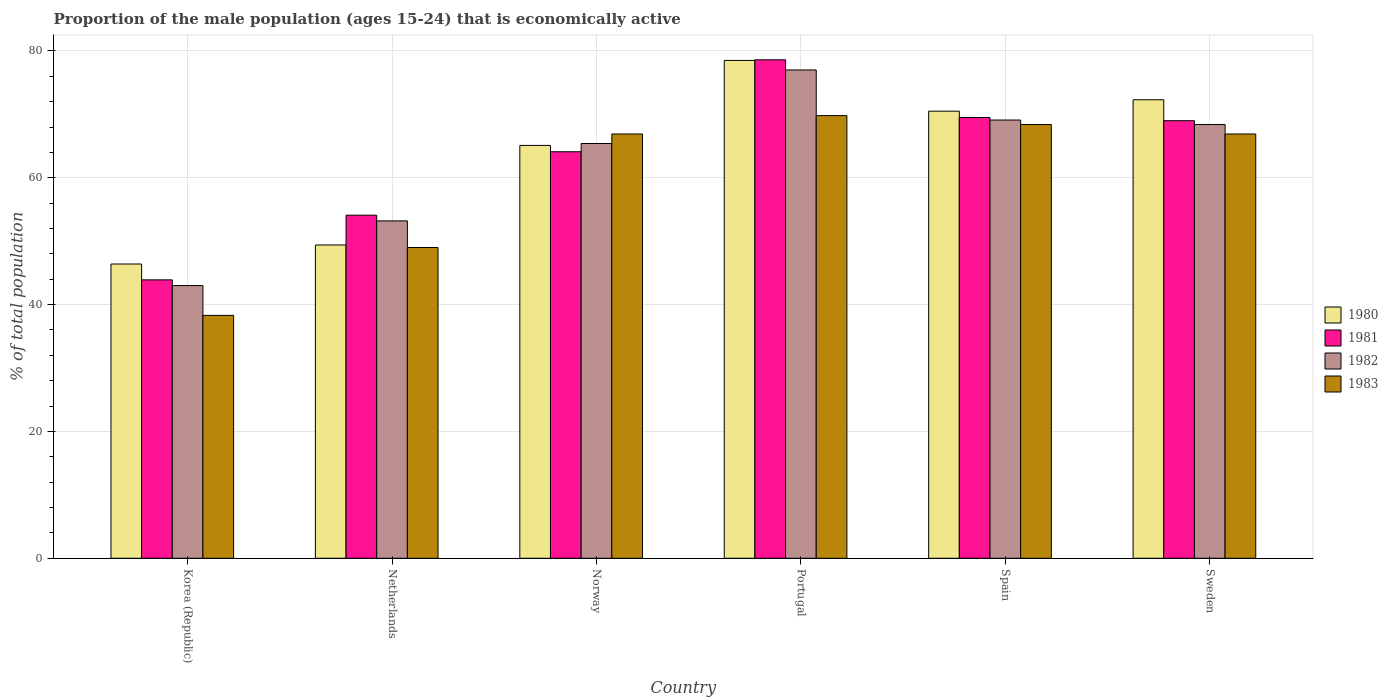Are the number of bars per tick equal to the number of legend labels?
Offer a very short reply. Yes. Are the number of bars on each tick of the X-axis equal?
Provide a succinct answer. Yes. How many bars are there on the 5th tick from the left?
Your answer should be compact. 4. What is the label of the 6th group of bars from the left?
Make the answer very short. Sweden. What is the proportion of the male population that is economically active in 1983 in Sweden?
Offer a very short reply. 66.9. Across all countries, what is the maximum proportion of the male population that is economically active in 1980?
Provide a succinct answer. 78.5. What is the total proportion of the male population that is economically active in 1982 in the graph?
Your answer should be compact. 376.1. What is the difference between the proportion of the male population that is economically active in 1981 in Netherlands and that in Norway?
Keep it short and to the point. -10. What is the difference between the proportion of the male population that is economically active in 1982 in Norway and the proportion of the male population that is economically active in 1983 in Korea (Republic)?
Your answer should be very brief. 27.1. What is the average proportion of the male population that is economically active in 1983 per country?
Make the answer very short. 59.88. What is the difference between the proportion of the male population that is economically active of/in 1981 and proportion of the male population that is economically active of/in 1983 in Korea (Republic)?
Offer a terse response. 5.6. In how many countries, is the proportion of the male population that is economically active in 1983 greater than 48 %?
Your response must be concise. 5. What is the ratio of the proportion of the male population that is economically active in 1981 in Spain to that in Sweden?
Offer a very short reply. 1.01. Is the difference between the proportion of the male population that is economically active in 1981 in Portugal and Spain greater than the difference between the proportion of the male population that is economically active in 1983 in Portugal and Spain?
Your response must be concise. Yes. What is the difference between the highest and the second highest proportion of the male population that is economically active in 1982?
Provide a succinct answer. -7.9. What is the difference between the highest and the lowest proportion of the male population that is economically active in 1981?
Provide a short and direct response. 34.7. Is the sum of the proportion of the male population that is economically active in 1981 in Netherlands and Norway greater than the maximum proportion of the male population that is economically active in 1983 across all countries?
Make the answer very short. Yes. Is it the case that in every country, the sum of the proportion of the male population that is economically active in 1980 and proportion of the male population that is economically active in 1983 is greater than the sum of proportion of the male population that is economically active in 1982 and proportion of the male population that is economically active in 1981?
Make the answer very short. No. How many bars are there?
Give a very brief answer. 24. How many countries are there in the graph?
Keep it short and to the point. 6. How are the legend labels stacked?
Provide a short and direct response. Vertical. What is the title of the graph?
Your answer should be compact. Proportion of the male population (ages 15-24) that is economically active. What is the label or title of the Y-axis?
Your response must be concise. % of total population. What is the % of total population of 1980 in Korea (Republic)?
Your response must be concise. 46.4. What is the % of total population of 1981 in Korea (Republic)?
Offer a terse response. 43.9. What is the % of total population of 1982 in Korea (Republic)?
Give a very brief answer. 43. What is the % of total population of 1983 in Korea (Republic)?
Make the answer very short. 38.3. What is the % of total population of 1980 in Netherlands?
Offer a very short reply. 49.4. What is the % of total population in 1981 in Netherlands?
Provide a succinct answer. 54.1. What is the % of total population in 1982 in Netherlands?
Make the answer very short. 53.2. What is the % of total population of 1980 in Norway?
Provide a short and direct response. 65.1. What is the % of total population of 1981 in Norway?
Your response must be concise. 64.1. What is the % of total population of 1982 in Norway?
Your response must be concise. 65.4. What is the % of total population in 1983 in Norway?
Offer a very short reply. 66.9. What is the % of total population in 1980 in Portugal?
Keep it short and to the point. 78.5. What is the % of total population of 1981 in Portugal?
Ensure brevity in your answer.  78.6. What is the % of total population in 1982 in Portugal?
Your answer should be compact. 77. What is the % of total population in 1983 in Portugal?
Provide a succinct answer. 69.8. What is the % of total population in 1980 in Spain?
Ensure brevity in your answer.  70.5. What is the % of total population in 1981 in Spain?
Keep it short and to the point. 69.5. What is the % of total population in 1982 in Spain?
Offer a terse response. 69.1. What is the % of total population in 1983 in Spain?
Make the answer very short. 68.4. What is the % of total population in 1980 in Sweden?
Give a very brief answer. 72.3. What is the % of total population in 1982 in Sweden?
Keep it short and to the point. 68.4. What is the % of total population of 1983 in Sweden?
Ensure brevity in your answer.  66.9. Across all countries, what is the maximum % of total population in 1980?
Ensure brevity in your answer.  78.5. Across all countries, what is the maximum % of total population in 1981?
Make the answer very short. 78.6. Across all countries, what is the maximum % of total population in 1982?
Your response must be concise. 77. Across all countries, what is the maximum % of total population of 1983?
Provide a succinct answer. 69.8. Across all countries, what is the minimum % of total population of 1980?
Keep it short and to the point. 46.4. Across all countries, what is the minimum % of total population of 1981?
Give a very brief answer. 43.9. Across all countries, what is the minimum % of total population in 1983?
Offer a terse response. 38.3. What is the total % of total population of 1980 in the graph?
Provide a short and direct response. 382.2. What is the total % of total population in 1981 in the graph?
Give a very brief answer. 379.2. What is the total % of total population in 1982 in the graph?
Keep it short and to the point. 376.1. What is the total % of total population of 1983 in the graph?
Your response must be concise. 359.3. What is the difference between the % of total population in 1981 in Korea (Republic) and that in Netherlands?
Keep it short and to the point. -10.2. What is the difference between the % of total population in 1980 in Korea (Republic) and that in Norway?
Your answer should be very brief. -18.7. What is the difference between the % of total population in 1981 in Korea (Republic) and that in Norway?
Your answer should be very brief. -20.2. What is the difference between the % of total population of 1982 in Korea (Republic) and that in Norway?
Your response must be concise. -22.4. What is the difference between the % of total population of 1983 in Korea (Republic) and that in Norway?
Keep it short and to the point. -28.6. What is the difference between the % of total population of 1980 in Korea (Republic) and that in Portugal?
Ensure brevity in your answer.  -32.1. What is the difference between the % of total population of 1981 in Korea (Republic) and that in Portugal?
Keep it short and to the point. -34.7. What is the difference between the % of total population in 1982 in Korea (Republic) and that in Portugal?
Give a very brief answer. -34. What is the difference between the % of total population of 1983 in Korea (Republic) and that in Portugal?
Your response must be concise. -31.5. What is the difference between the % of total population of 1980 in Korea (Republic) and that in Spain?
Provide a short and direct response. -24.1. What is the difference between the % of total population of 1981 in Korea (Republic) and that in Spain?
Provide a short and direct response. -25.6. What is the difference between the % of total population of 1982 in Korea (Republic) and that in Spain?
Provide a short and direct response. -26.1. What is the difference between the % of total population in 1983 in Korea (Republic) and that in Spain?
Provide a succinct answer. -30.1. What is the difference between the % of total population in 1980 in Korea (Republic) and that in Sweden?
Your answer should be compact. -25.9. What is the difference between the % of total population in 1981 in Korea (Republic) and that in Sweden?
Make the answer very short. -25.1. What is the difference between the % of total population in 1982 in Korea (Republic) and that in Sweden?
Your answer should be compact. -25.4. What is the difference between the % of total population of 1983 in Korea (Republic) and that in Sweden?
Offer a very short reply. -28.6. What is the difference between the % of total population of 1980 in Netherlands and that in Norway?
Ensure brevity in your answer.  -15.7. What is the difference between the % of total population in 1981 in Netherlands and that in Norway?
Provide a short and direct response. -10. What is the difference between the % of total population of 1983 in Netherlands and that in Norway?
Your response must be concise. -17.9. What is the difference between the % of total population in 1980 in Netherlands and that in Portugal?
Make the answer very short. -29.1. What is the difference between the % of total population in 1981 in Netherlands and that in Portugal?
Make the answer very short. -24.5. What is the difference between the % of total population of 1982 in Netherlands and that in Portugal?
Offer a very short reply. -23.8. What is the difference between the % of total population of 1983 in Netherlands and that in Portugal?
Your answer should be very brief. -20.8. What is the difference between the % of total population of 1980 in Netherlands and that in Spain?
Keep it short and to the point. -21.1. What is the difference between the % of total population of 1981 in Netherlands and that in Spain?
Ensure brevity in your answer.  -15.4. What is the difference between the % of total population in 1982 in Netherlands and that in Spain?
Provide a short and direct response. -15.9. What is the difference between the % of total population of 1983 in Netherlands and that in Spain?
Give a very brief answer. -19.4. What is the difference between the % of total population of 1980 in Netherlands and that in Sweden?
Offer a terse response. -22.9. What is the difference between the % of total population in 1981 in Netherlands and that in Sweden?
Ensure brevity in your answer.  -14.9. What is the difference between the % of total population of 1982 in Netherlands and that in Sweden?
Give a very brief answer. -15.2. What is the difference between the % of total population of 1983 in Netherlands and that in Sweden?
Offer a terse response. -17.9. What is the difference between the % of total population in 1980 in Norway and that in Portugal?
Your answer should be compact. -13.4. What is the difference between the % of total population in 1982 in Norway and that in Portugal?
Offer a terse response. -11.6. What is the difference between the % of total population of 1983 in Norway and that in Portugal?
Your answer should be very brief. -2.9. What is the difference between the % of total population of 1982 in Norway and that in Spain?
Provide a succinct answer. -3.7. What is the difference between the % of total population in 1983 in Norway and that in Spain?
Offer a very short reply. -1.5. What is the difference between the % of total population of 1980 in Portugal and that in Sweden?
Your answer should be compact. 6.2. What is the difference between the % of total population of 1983 in Spain and that in Sweden?
Your answer should be very brief. 1.5. What is the difference between the % of total population of 1980 in Korea (Republic) and the % of total population of 1983 in Netherlands?
Make the answer very short. -2.6. What is the difference between the % of total population in 1981 in Korea (Republic) and the % of total population in 1983 in Netherlands?
Your answer should be very brief. -5.1. What is the difference between the % of total population of 1982 in Korea (Republic) and the % of total population of 1983 in Netherlands?
Your answer should be very brief. -6. What is the difference between the % of total population in 1980 in Korea (Republic) and the % of total population in 1981 in Norway?
Provide a succinct answer. -17.7. What is the difference between the % of total population of 1980 in Korea (Republic) and the % of total population of 1982 in Norway?
Provide a short and direct response. -19. What is the difference between the % of total population in 1980 in Korea (Republic) and the % of total population in 1983 in Norway?
Offer a very short reply. -20.5. What is the difference between the % of total population in 1981 in Korea (Republic) and the % of total population in 1982 in Norway?
Offer a very short reply. -21.5. What is the difference between the % of total population of 1981 in Korea (Republic) and the % of total population of 1983 in Norway?
Keep it short and to the point. -23. What is the difference between the % of total population of 1982 in Korea (Republic) and the % of total population of 1983 in Norway?
Offer a terse response. -23.9. What is the difference between the % of total population of 1980 in Korea (Republic) and the % of total population of 1981 in Portugal?
Your answer should be compact. -32.2. What is the difference between the % of total population in 1980 in Korea (Republic) and the % of total population in 1982 in Portugal?
Keep it short and to the point. -30.6. What is the difference between the % of total population of 1980 in Korea (Republic) and the % of total population of 1983 in Portugal?
Provide a succinct answer. -23.4. What is the difference between the % of total population of 1981 in Korea (Republic) and the % of total population of 1982 in Portugal?
Your response must be concise. -33.1. What is the difference between the % of total population in 1981 in Korea (Republic) and the % of total population in 1983 in Portugal?
Your response must be concise. -25.9. What is the difference between the % of total population in 1982 in Korea (Republic) and the % of total population in 1983 in Portugal?
Give a very brief answer. -26.8. What is the difference between the % of total population in 1980 in Korea (Republic) and the % of total population in 1981 in Spain?
Ensure brevity in your answer.  -23.1. What is the difference between the % of total population in 1980 in Korea (Republic) and the % of total population in 1982 in Spain?
Your answer should be very brief. -22.7. What is the difference between the % of total population of 1981 in Korea (Republic) and the % of total population of 1982 in Spain?
Provide a succinct answer. -25.2. What is the difference between the % of total population in 1981 in Korea (Republic) and the % of total population in 1983 in Spain?
Offer a terse response. -24.5. What is the difference between the % of total population of 1982 in Korea (Republic) and the % of total population of 1983 in Spain?
Keep it short and to the point. -25.4. What is the difference between the % of total population of 1980 in Korea (Republic) and the % of total population of 1981 in Sweden?
Keep it short and to the point. -22.6. What is the difference between the % of total population of 1980 in Korea (Republic) and the % of total population of 1982 in Sweden?
Your answer should be compact. -22. What is the difference between the % of total population of 1980 in Korea (Republic) and the % of total population of 1983 in Sweden?
Provide a short and direct response. -20.5. What is the difference between the % of total population in 1981 in Korea (Republic) and the % of total population in 1982 in Sweden?
Provide a succinct answer. -24.5. What is the difference between the % of total population in 1981 in Korea (Republic) and the % of total population in 1983 in Sweden?
Offer a very short reply. -23. What is the difference between the % of total population of 1982 in Korea (Republic) and the % of total population of 1983 in Sweden?
Ensure brevity in your answer.  -23.9. What is the difference between the % of total population of 1980 in Netherlands and the % of total population of 1981 in Norway?
Provide a short and direct response. -14.7. What is the difference between the % of total population of 1980 in Netherlands and the % of total population of 1983 in Norway?
Offer a very short reply. -17.5. What is the difference between the % of total population in 1982 in Netherlands and the % of total population in 1983 in Norway?
Offer a very short reply. -13.7. What is the difference between the % of total population of 1980 in Netherlands and the % of total population of 1981 in Portugal?
Your answer should be very brief. -29.2. What is the difference between the % of total population of 1980 in Netherlands and the % of total population of 1982 in Portugal?
Provide a succinct answer. -27.6. What is the difference between the % of total population in 1980 in Netherlands and the % of total population in 1983 in Portugal?
Offer a very short reply. -20.4. What is the difference between the % of total population of 1981 in Netherlands and the % of total population of 1982 in Portugal?
Your answer should be very brief. -22.9. What is the difference between the % of total population in 1981 in Netherlands and the % of total population in 1983 in Portugal?
Your response must be concise. -15.7. What is the difference between the % of total population in 1982 in Netherlands and the % of total population in 1983 in Portugal?
Your response must be concise. -16.6. What is the difference between the % of total population in 1980 in Netherlands and the % of total population in 1981 in Spain?
Ensure brevity in your answer.  -20.1. What is the difference between the % of total population in 1980 in Netherlands and the % of total population in 1982 in Spain?
Your response must be concise. -19.7. What is the difference between the % of total population of 1981 in Netherlands and the % of total population of 1983 in Spain?
Your answer should be compact. -14.3. What is the difference between the % of total population of 1982 in Netherlands and the % of total population of 1983 in Spain?
Offer a terse response. -15.2. What is the difference between the % of total population in 1980 in Netherlands and the % of total population in 1981 in Sweden?
Your answer should be very brief. -19.6. What is the difference between the % of total population in 1980 in Netherlands and the % of total population in 1982 in Sweden?
Ensure brevity in your answer.  -19. What is the difference between the % of total population of 1980 in Netherlands and the % of total population of 1983 in Sweden?
Make the answer very short. -17.5. What is the difference between the % of total population of 1981 in Netherlands and the % of total population of 1982 in Sweden?
Your response must be concise. -14.3. What is the difference between the % of total population in 1981 in Netherlands and the % of total population in 1983 in Sweden?
Keep it short and to the point. -12.8. What is the difference between the % of total population in 1982 in Netherlands and the % of total population in 1983 in Sweden?
Offer a very short reply. -13.7. What is the difference between the % of total population of 1980 in Norway and the % of total population of 1981 in Portugal?
Ensure brevity in your answer.  -13.5. What is the difference between the % of total population in 1980 in Norway and the % of total population in 1982 in Portugal?
Your answer should be compact. -11.9. What is the difference between the % of total population of 1981 in Norway and the % of total population of 1982 in Portugal?
Offer a terse response. -12.9. What is the difference between the % of total population in 1982 in Norway and the % of total population in 1983 in Portugal?
Your answer should be compact. -4.4. What is the difference between the % of total population in 1980 in Norway and the % of total population in 1981 in Spain?
Your answer should be compact. -4.4. What is the difference between the % of total population in 1981 in Norway and the % of total population in 1982 in Spain?
Make the answer very short. -5. What is the difference between the % of total population in 1981 in Norway and the % of total population in 1983 in Spain?
Ensure brevity in your answer.  -4.3. What is the difference between the % of total population of 1982 in Norway and the % of total population of 1983 in Spain?
Your answer should be compact. -3. What is the difference between the % of total population of 1980 in Norway and the % of total population of 1981 in Sweden?
Provide a succinct answer. -3.9. What is the difference between the % of total population in 1980 in Norway and the % of total population in 1982 in Sweden?
Provide a short and direct response. -3.3. What is the difference between the % of total population of 1980 in Norway and the % of total population of 1983 in Sweden?
Offer a terse response. -1.8. What is the difference between the % of total population in 1981 in Norway and the % of total population in 1983 in Sweden?
Offer a very short reply. -2.8. What is the difference between the % of total population of 1982 in Norway and the % of total population of 1983 in Sweden?
Your answer should be very brief. -1.5. What is the difference between the % of total population in 1980 in Portugal and the % of total population in 1982 in Spain?
Keep it short and to the point. 9.4. What is the difference between the % of total population in 1980 in Portugal and the % of total population in 1983 in Spain?
Offer a terse response. 10.1. What is the difference between the % of total population of 1982 in Portugal and the % of total population of 1983 in Spain?
Your response must be concise. 8.6. What is the difference between the % of total population of 1980 in Portugal and the % of total population of 1982 in Sweden?
Make the answer very short. 10.1. What is the difference between the % of total population in 1981 in Portugal and the % of total population in 1983 in Sweden?
Offer a terse response. 11.7. What is the difference between the % of total population of 1980 in Spain and the % of total population of 1982 in Sweden?
Offer a very short reply. 2.1. What is the difference between the % of total population of 1981 in Spain and the % of total population of 1983 in Sweden?
Make the answer very short. 2.6. What is the average % of total population in 1980 per country?
Provide a succinct answer. 63.7. What is the average % of total population of 1981 per country?
Keep it short and to the point. 63.2. What is the average % of total population of 1982 per country?
Keep it short and to the point. 62.68. What is the average % of total population in 1983 per country?
Make the answer very short. 59.88. What is the difference between the % of total population of 1980 and % of total population of 1982 in Korea (Republic)?
Your response must be concise. 3.4. What is the difference between the % of total population of 1980 and % of total population of 1983 in Korea (Republic)?
Your answer should be compact. 8.1. What is the difference between the % of total population of 1981 and % of total population of 1983 in Korea (Republic)?
Your response must be concise. 5.6. What is the difference between the % of total population in 1982 and % of total population in 1983 in Korea (Republic)?
Your response must be concise. 4.7. What is the difference between the % of total population in 1980 and % of total population in 1981 in Netherlands?
Offer a very short reply. -4.7. What is the difference between the % of total population in 1980 and % of total population in 1982 in Netherlands?
Offer a terse response. -3.8. What is the difference between the % of total population in 1980 and % of total population in 1983 in Netherlands?
Provide a succinct answer. 0.4. What is the difference between the % of total population in 1981 and % of total population in 1983 in Netherlands?
Give a very brief answer. 5.1. What is the difference between the % of total population of 1982 and % of total population of 1983 in Netherlands?
Keep it short and to the point. 4.2. What is the difference between the % of total population in 1980 and % of total population in 1981 in Norway?
Your response must be concise. 1. What is the difference between the % of total population of 1980 and % of total population of 1982 in Norway?
Ensure brevity in your answer.  -0.3. What is the difference between the % of total population of 1980 and % of total population of 1983 in Norway?
Provide a succinct answer. -1.8. What is the difference between the % of total population in 1980 and % of total population in 1982 in Portugal?
Offer a terse response. 1.5. What is the difference between the % of total population of 1981 and % of total population of 1982 in Portugal?
Ensure brevity in your answer.  1.6. What is the difference between the % of total population in 1981 and % of total population in 1983 in Portugal?
Provide a short and direct response. 8.8. What is the difference between the % of total population of 1980 and % of total population of 1982 in Spain?
Offer a very short reply. 1.4. What is the difference between the % of total population in 1981 and % of total population in 1983 in Spain?
Make the answer very short. 1.1. What is the difference between the % of total population of 1980 and % of total population of 1982 in Sweden?
Your response must be concise. 3.9. What is the difference between the % of total population in 1980 and % of total population in 1983 in Sweden?
Offer a terse response. 5.4. What is the difference between the % of total population in 1981 and % of total population in 1982 in Sweden?
Your answer should be compact. 0.6. What is the difference between the % of total population in 1982 and % of total population in 1983 in Sweden?
Offer a terse response. 1.5. What is the ratio of the % of total population of 1980 in Korea (Republic) to that in Netherlands?
Keep it short and to the point. 0.94. What is the ratio of the % of total population in 1981 in Korea (Republic) to that in Netherlands?
Offer a terse response. 0.81. What is the ratio of the % of total population in 1982 in Korea (Republic) to that in Netherlands?
Give a very brief answer. 0.81. What is the ratio of the % of total population of 1983 in Korea (Republic) to that in Netherlands?
Offer a terse response. 0.78. What is the ratio of the % of total population of 1980 in Korea (Republic) to that in Norway?
Ensure brevity in your answer.  0.71. What is the ratio of the % of total population of 1981 in Korea (Republic) to that in Norway?
Provide a short and direct response. 0.68. What is the ratio of the % of total population of 1982 in Korea (Republic) to that in Norway?
Provide a short and direct response. 0.66. What is the ratio of the % of total population of 1983 in Korea (Republic) to that in Norway?
Provide a succinct answer. 0.57. What is the ratio of the % of total population in 1980 in Korea (Republic) to that in Portugal?
Your response must be concise. 0.59. What is the ratio of the % of total population of 1981 in Korea (Republic) to that in Portugal?
Provide a short and direct response. 0.56. What is the ratio of the % of total population of 1982 in Korea (Republic) to that in Portugal?
Your answer should be very brief. 0.56. What is the ratio of the % of total population of 1983 in Korea (Republic) to that in Portugal?
Your answer should be very brief. 0.55. What is the ratio of the % of total population of 1980 in Korea (Republic) to that in Spain?
Keep it short and to the point. 0.66. What is the ratio of the % of total population in 1981 in Korea (Republic) to that in Spain?
Keep it short and to the point. 0.63. What is the ratio of the % of total population in 1982 in Korea (Republic) to that in Spain?
Provide a succinct answer. 0.62. What is the ratio of the % of total population in 1983 in Korea (Republic) to that in Spain?
Keep it short and to the point. 0.56. What is the ratio of the % of total population in 1980 in Korea (Republic) to that in Sweden?
Offer a terse response. 0.64. What is the ratio of the % of total population in 1981 in Korea (Republic) to that in Sweden?
Offer a very short reply. 0.64. What is the ratio of the % of total population of 1982 in Korea (Republic) to that in Sweden?
Your response must be concise. 0.63. What is the ratio of the % of total population in 1983 in Korea (Republic) to that in Sweden?
Your answer should be compact. 0.57. What is the ratio of the % of total population of 1980 in Netherlands to that in Norway?
Your response must be concise. 0.76. What is the ratio of the % of total population in 1981 in Netherlands to that in Norway?
Your response must be concise. 0.84. What is the ratio of the % of total population of 1982 in Netherlands to that in Norway?
Your answer should be very brief. 0.81. What is the ratio of the % of total population in 1983 in Netherlands to that in Norway?
Give a very brief answer. 0.73. What is the ratio of the % of total population of 1980 in Netherlands to that in Portugal?
Your answer should be compact. 0.63. What is the ratio of the % of total population of 1981 in Netherlands to that in Portugal?
Your response must be concise. 0.69. What is the ratio of the % of total population of 1982 in Netherlands to that in Portugal?
Keep it short and to the point. 0.69. What is the ratio of the % of total population in 1983 in Netherlands to that in Portugal?
Provide a succinct answer. 0.7. What is the ratio of the % of total population in 1980 in Netherlands to that in Spain?
Offer a very short reply. 0.7. What is the ratio of the % of total population of 1981 in Netherlands to that in Spain?
Ensure brevity in your answer.  0.78. What is the ratio of the % of total population of 1982 in Netherlands to that in Spain?
Your answer should be very brief. 0.77. What is the ratio of the % of total population of 1983 in Netherlands to that in Spain?
Your response must be concise. 0.72. What is the ratio of the % of total population in 1980 in Netherlands to that in Sweden?
Offer a terse response. 0.68. What is the ratio of the % of total population in 1981 in Netherlands to that in Sweden?
Your answer should be compact. 0.78. What is the ratio of the % of total population in 1983 in Netherlands to that in Sweden?
Ensure brevity in your answer.  0.73. What is the ratio of the % of total population of 1980 in Norway to that in Portugal?
Your answer should be compact. 0.83. What is the ratio of the % of total population in 1981 in Norway to that in Portugal?
Your response must be concise. 0.82. What is the ratio of the % of total population in 1982 in Norway to that in Portugal?
Keep it short and to the point. 0.85. What is the ratio of the % of total population in 1983 in Norway to that in Portugal?
Your response must be concise. 0.96. What is the ratio of the % of total population in 1980 in Norway to that in Spain?
Your response must be concise. 0.92. What is the ratio of the % of total population in 1981 in Norway to that in Spain?
Provide a succinct answer. 0.92. What is the ratio of the % of total population of 1982 in Norway to that in Spain?
Your answer should be very brief. 0.95. What is the ratio of the % of total population of 1983 in Norway to that in Spain?
Ensure brevity in your answer.  0.98. What is the ratio of the % of total population in 1980 in Norway to that in Sweden?
Provide a succinct answer. 0.9. What is the ratio of the % of total population of 1981 in Norway to that in Sweden?
Ensure brevity in your answer.  0.93. What is the ratio of the % of total population in 1982 in Norway to that in Sweden?
Your answer should be very brief. 0.96. What is the ratio of the % of total population of 1983 in Norway to that in Sweden?
Provide a short and direct response. 1. What is the ratio of the % of total population in 1980 in Portugal to that in Spain?
Your response must be concise. 1.11. What is the ratio of the % of total population in 1981 in Portugal to that in Spain?
Offer a very short reply. 1.13. What is the ratio of the % of total population of 1982 in Portugal to that in Spain?
Provide a succinct answer. 1.11. What is the ratio of the % of total population in 1983 in Portugal to that in Spain?
Your answer should be compact. 1.02. What is the ratio of the % of total population of 1980 in Portugal to that in Sweden?
Give a very brief answer. 1.09. What is the ratio of the % of total population of 1981 in Portugal to that in Sweden?
Provide a short and direct response. 1.14. What is the ratio of the % of total population of 1982 in Portugal to that in Sweden?
Ensure brevity in your answer.  1.13. What is the ratio of the % of total population of 1983 in Portugal to that in Sweden?
Provide a short and direct response. 1.04. What is the ratio of the % of total population of 1980 in Spain to that in Sweden?
Make the answer very short. 0.98. What is the ratio of the % of total population in 1982 in Spain to that in Sweden?
Give a very brief answer. 1.01. What is the ratio of the % of total population in 1983 in Spain to that in Sweden?
Your answer should be compact. 1.02. What is the difference between the highest and the second highest % of total population in 1981?
Make the answer very short. 9.1. What is the difference between the highest and the second highest % of total population in 1983?
Make the answer very short. 1.4. What is the difference between the highest and the lowest % of total population of 1980?
Your answer should be compact. 32.1. What is the difference between the highest and the lowest % of total population in 1981?
Ensure brevity in your answer.  34.7. What is the difference between the highest and the lowest % of total population in 1983?
Make the answer very short. 31.5. 